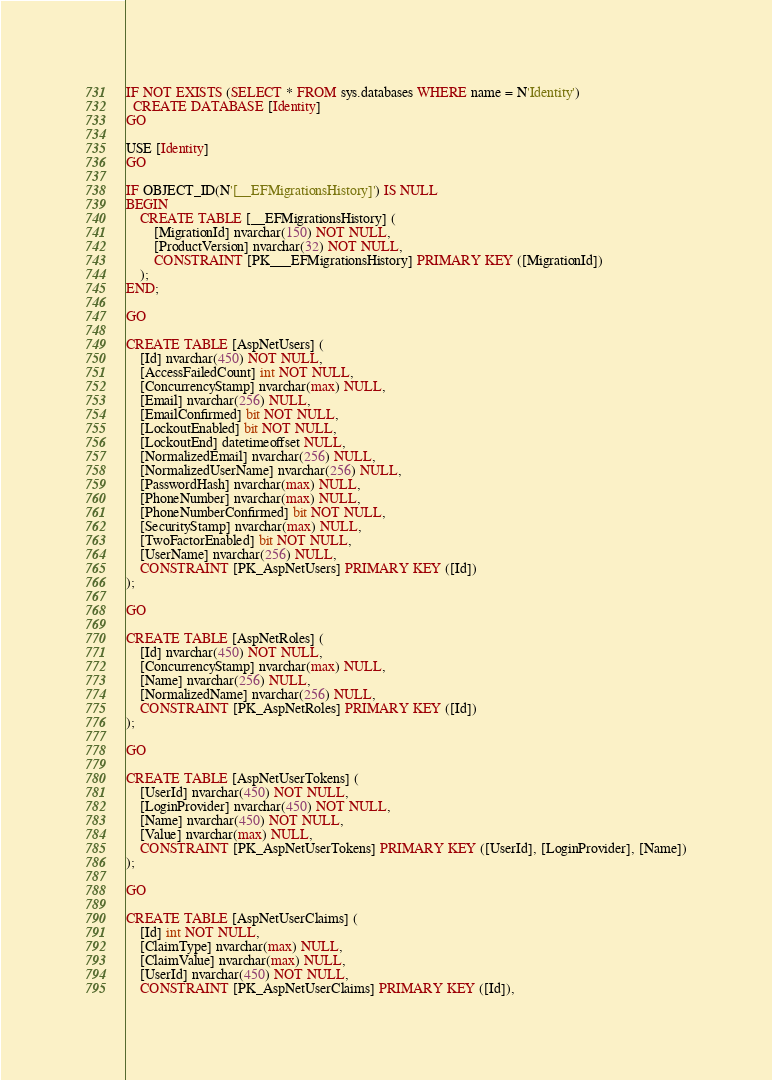Convert code to text. <code><loc_0><loc_0><loc_500><loc_500><_SQL_>IF NOT EXISTS (SELECT * FROM sys.databases WHERE name = N'Identity')
  CREATE DATABASE [Identity]
GO

USE [Identity]
GO

IF OBJECT_ID(N'[__EFMigrationsHistory]') IS NULL
BEGIN
    CREATE TABLE [__EFMigrationsHistory] (
        [MigrationId] nvarchar(150) NOT NULL,
        [ProductVersion] nvarchar(32) NOT NULL,
        CONSTRAINT [PK___EFMigrationsHistory] PRIMARY KEY ([MigrationId])
    );
END;

GO

CREATE TABLE [AspNetUsers] (
    [Id] nvarchar(450) NOT NULL,
    [AccessFailedCount] int NOT NULL,
    [ConcurrencyStamp] nvarchar(max) NULL,
    [Email] nvarchar(256) NULL,
    [EmailConfirmed] bit NOT NULL,
    [LockoutEnabled] bit NOT NULL,
    [LockoutEnd] datetimeoffset NULL,
    [NormalizedEmail] nvarchar(256) NULL,
    [NormalizedUserName] nvarchar(256) NULL,
    [PasswordHash] nvarchar(max) NULL,
    [PhoneNumber] nvarchar(max) NULL,
    [PhoneNumberConfirmed] bit NOT NULL,
    [SecurityStamp] nvarchar(max) NULL,
    [TwoFactorEnabled] bit NOT NULL,
    [UserName] nvarchar(256) NULL,
    CONSTRAINT [PK_AspNetUsers] PRIMARY KEY ([Id])
);

GO

CREATE TABLE [AspNetRoles] (
    [Id] nvarchar(450) NOT NULL,
    [ConcurrencyStamp] nvarchar(max) NULL,
    [Name] nvarchar(256) NULL,
    [NormalizedName] nvarchar(256) NULL,
    CONSTRAINT [PK_AspNetRoles] PRIMARY KEY ([Id])
);

GO

CREATE TABLE [AspNetUserTokens] (
    [UserId] nvarchar(450) NOT NULL,
    [LoginProvider] nvarchar(450) NOT NULL,
    [Name] nvarchar(450) NOT NULL,
    [Value] nvarchar(max) NULL,
    CONSTRAINT [PK_AspNetUserTokens] PRIMARY KEY ([UserId], [LoginProvider], [Name])
);

GO

CREATE TABLE [AspNetUserClaims] (
    [Id] int NOT NULL,
    [ClaimType] nvarchar(max) NULL,
    [ClaimValue] nvarchar(max) NULL,
    [UserId] nvarchar(450) NOT NULL,
    CONSTRAINT [PK_AspNetUserClaims] PRIMARY KEY ([Id]),</code> 